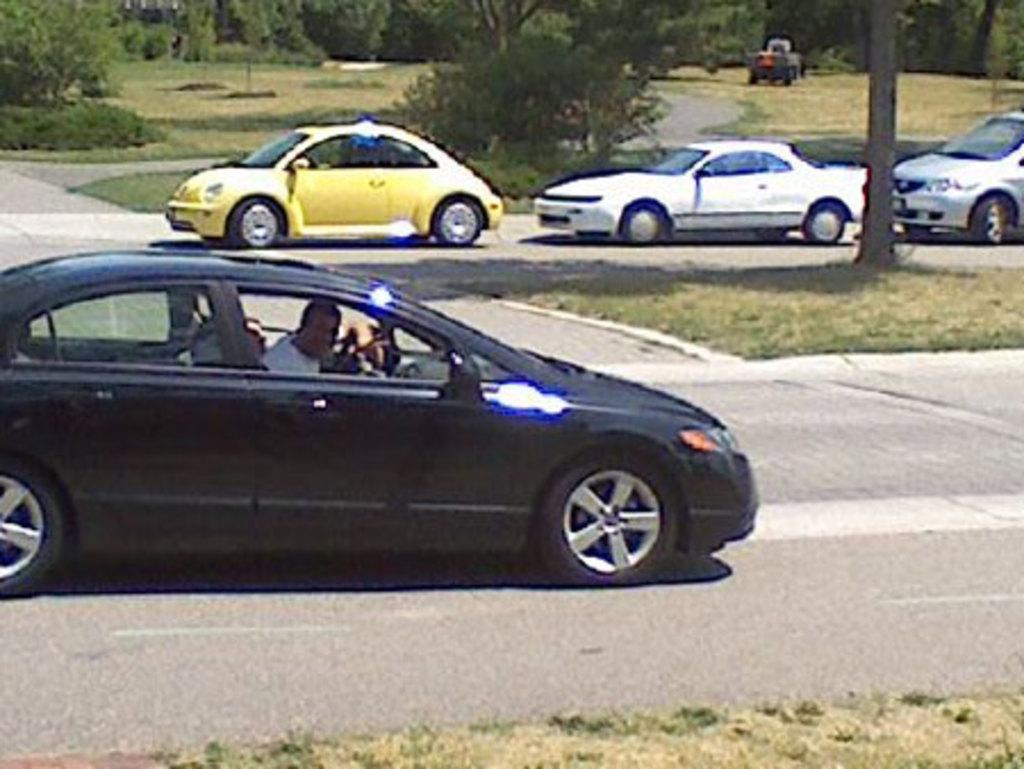What is present in the image? There are vehicles in the image. Can you describe the people in the image? Two persons are sitting in one of the vehicles. What can be seen in the background of the image? There are trees in the background of the image. What is the color of the trees? The trees are green in color. What type of argument is taking place between the trees in the image? There is no argument taking place between the trees in the image, as trees do not engage in arguments. 